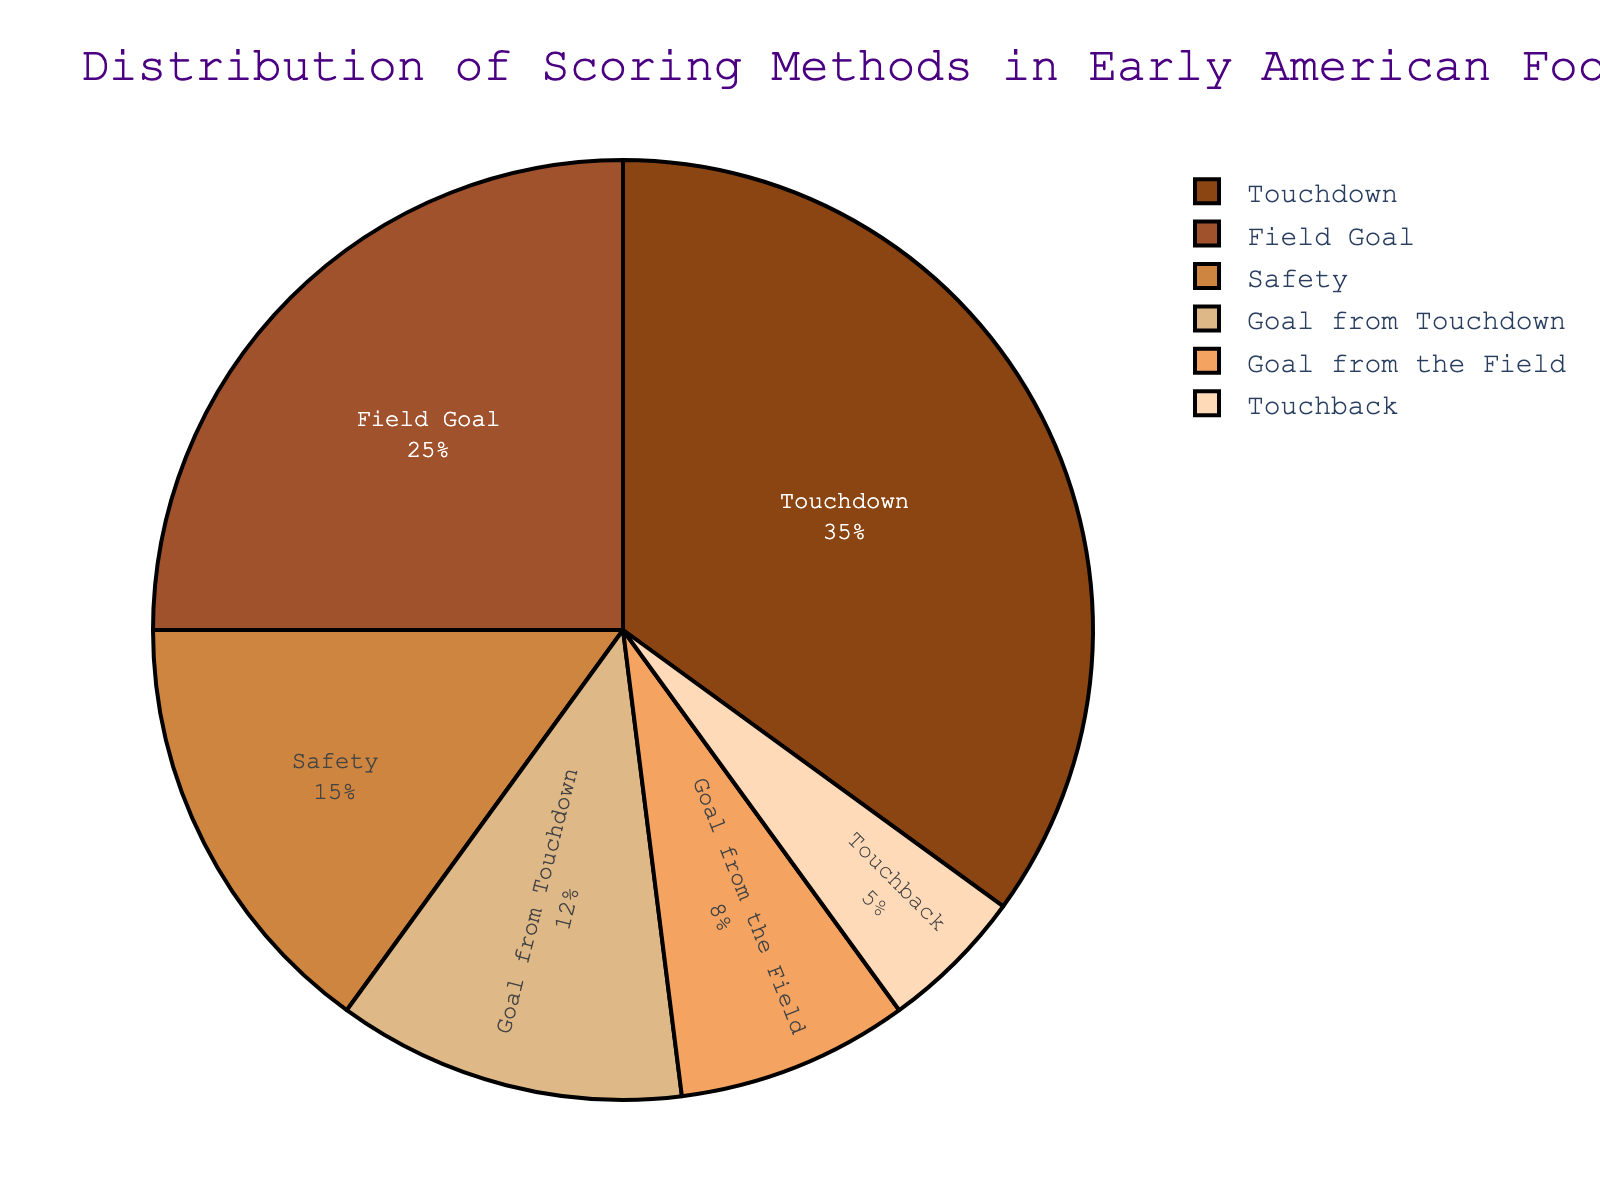What percentage of early American football scores were from touchdowns? The pie chart displays the percentage distribution of different scoring methods. Locate the segment labeled "Touchdown" to find the percentage.
Answer: 35% Which scoring method contributed the least to the overall scoring in early American football? Examine the pie chart and identify the smallest segment, which represents the scoring method with the smallest percentage.
Answer: Touchback By what percentage does the contribution of touchdowns exceed safeties? Subtract the percentage of safeties from the percentage of touchdowns: 35% (Touchdown) - 15% (Safety) = 20%
Answer: 20% What is the combined percentage of scoring methods related to goals (Goal from Touchdown and Goal from the Field)? Add the percentages of "Goal from Touchdown" and "Goal from the Field": 12% + 8% = 20%
Answer: 20% How does the percentage of field goals compare to that of touchbacks? Look at the pie chart to find the percentages for field goals (25%) and touchbacks (5%). Then, calculate the difference: 25% - 5% = 20%.
Answer: Field goals exceed touchbacks by 20% Are touchdowns the most frequent scoring method depicted in the chart? Find the segment with the highest percentage and check if it corresponds to touchdowns (35%).
Answer: Yes What is the difference in percentage between the second most frequent and the least frequent scoring methods? Identify the percentages of the second most frequent (Field Goal, 25%) and the least frequent (Touchback, 5%) methods. Calculate the difference: 25% - 5% = 20%.
Answer: 20% How much more frequent are touchdowns compared to goals from the field? Locate the percentages for touchdowns (35%) and goals from the field (8%). Subtract these values: 35% - 8% = 27%.
Answer: 27% What percentage of the scoring methods are not directly related to touchdowns (excluding touchdowns and goals from touchdowns)? Calculate the total percentage not involving touchdowns: 100% - (35% + 12%) = 53%.
Answer: 53% If safeties and goals from touchdowns are combined, what percentage of the entire scoring methods does this represent? Add the percentages of safeties and goals from touchdowns: 15% + 12% = 27%.
Answer: 27% 